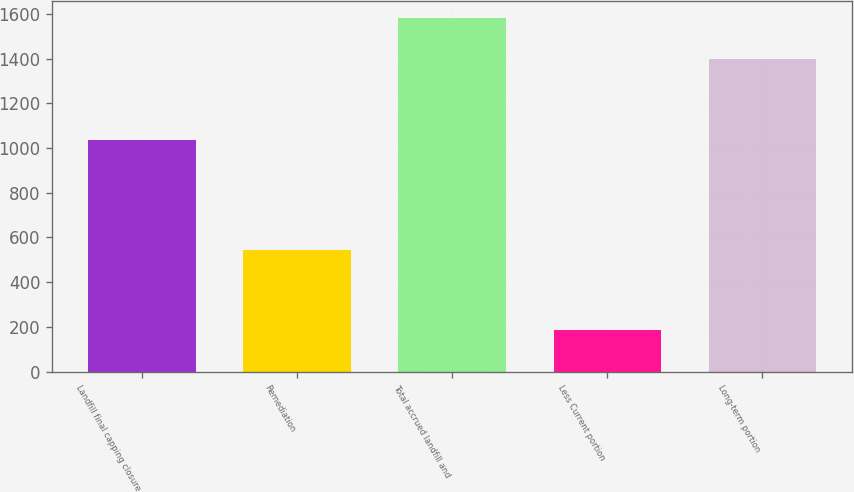Convert chart to OTSL. <chart><loc_0><loc_0><loc_500><loc_500><bar_chart><fcel>Landfill final capping closure<fcel>Remediation<fcel>Total accrued landfill and<fcel>Less Current portion<fcel>Long-term portion<nl><fcel>1037<fcel>543.7<fcel>1580.7<fcel>184.2<fcel>1396.5<nl></chart> 